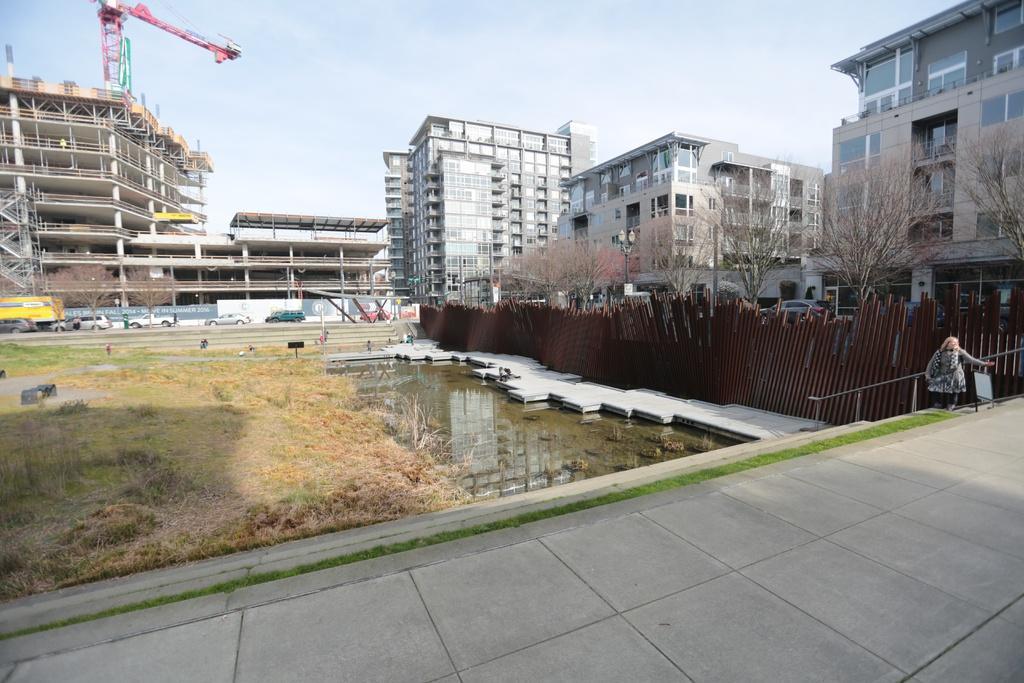Could you give a brief overview of what you see in this image? In this image we can see a building under construction, buildings, trees, wooden fence, water, grass, road, vehicles and sky. 